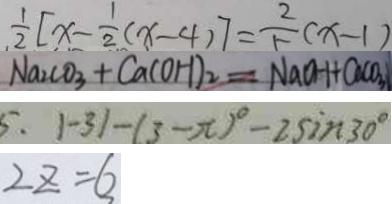<formula> <loc_0><loc_0><loc_500><loc_500>\frac { 1 } { 2 } [ x - \frac { 1 } { 2 } ( x - 4 ) ] = \frac { 2 } { 5 } ( x - 1 ) 
 N a _ { 2 } C O _ { 3 } + C a ( O H ) _ { 2 } = N a O H + C a C O _ { 3 } 
 5 . 1 - 3 1 - ( 3 - \pi ) ^ { \circ } - 2 \sin 3 0 ^ { \circ } 
 2 z = 6</formula> 